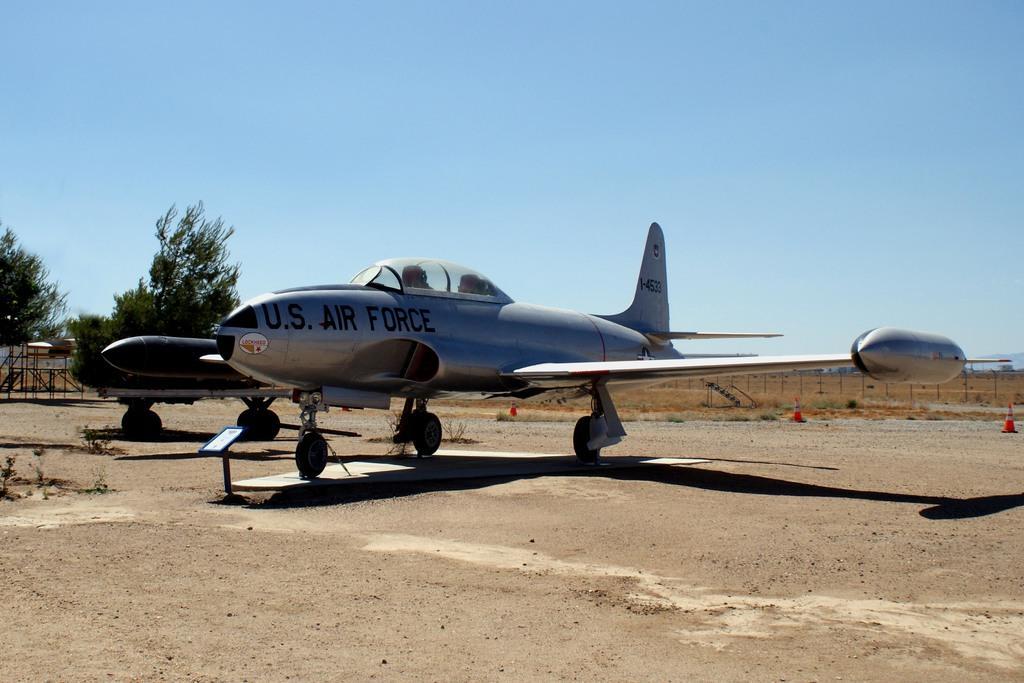Could you give a brief overview of what you see in this image? This image is clicked outside. There is an airplane in the middle. It has wings, wheels, propeller. There are trees on the left side. There is sky at the top. 